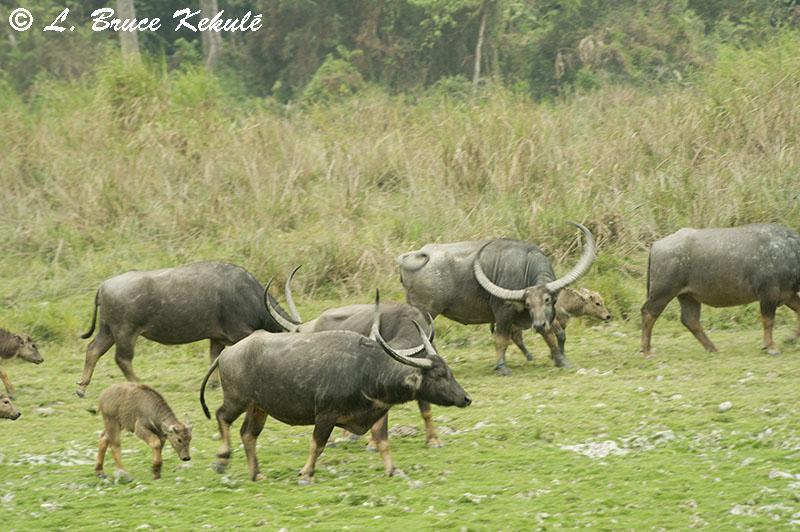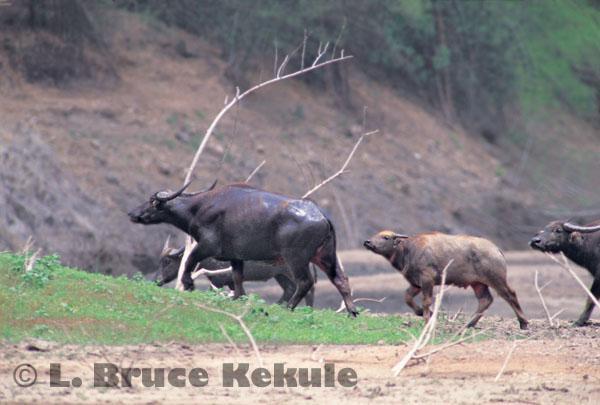The first image is the image on the left, the second image is the image on the right. Evaluate the accuracy of this statement regarding the images: "The animals in the left photo are standing in water.". Is it true? Answer yes or no. No. The first image is the image on the left, the second image is the image on the right. Given the left and right images, does the statement "Left image shows water buffalo standing in wet area." hold true? Answer yes or no. No. 